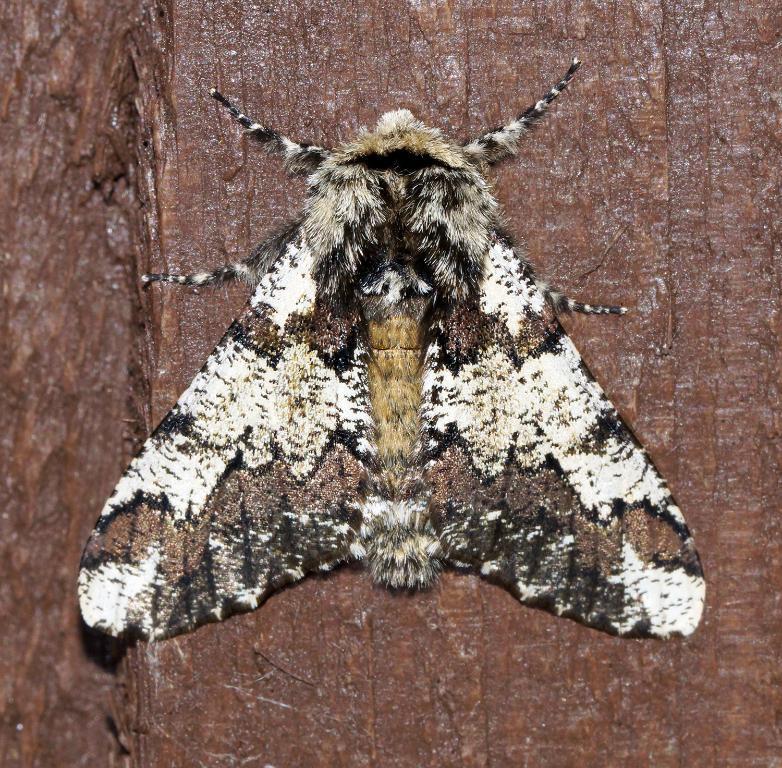Can you describe this image briefly? In this image I can see an insect which is cream, brown, white and black in color is on the brown colored object. 